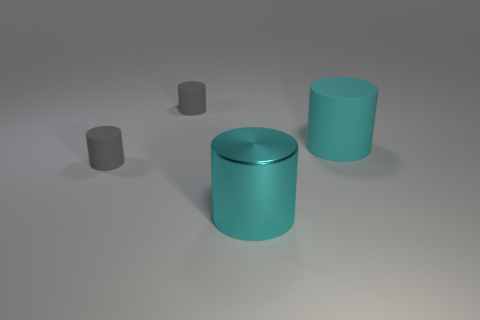What size is the rubber object that is in front of the big cyan matte thing that is behind the cyan metal cylinder?
Keep it short and to the point. Small. Does the large thing behind the big metal cylinder have the same color as the rubber cylinder that is behind the cyan rubber cylinder?
Your response must be concise. No. How many gray things are metal objects or tiny rubber cylinders?
Your response must be concise. 2. Are there fewer large cyan cylinders that are on the left side of the metallic object than gray cylinders that are in front of the cyan rubber thing?
Your answer should be compact. Yes. Is there a metallic cylinder of the same size as the cyan rubber cylinder?
Provide a succinct answer. Yes. Is the size of the cylinder that is behind the cyan rubber thing the same as the large cyan rubber object?
Provide a short and direct response. No. Is the number of cyan metal things greater than the number of matte cylinders?
Provide a short and direct response. No. Is there a cyan metallic object that has the same shape as the big rubber object?
Give a very brief answer. Yes. What shape is the small gray matte object that is in front of the big cyan matte cylinder?
Keep it short and to the point. Cylinder. What number of gray cylinders are in front of the cyan cylinder that is on the right side of the cyan shiny cylinder left of the large cyan matte object?
Ensure brevity in your answer.  1. 